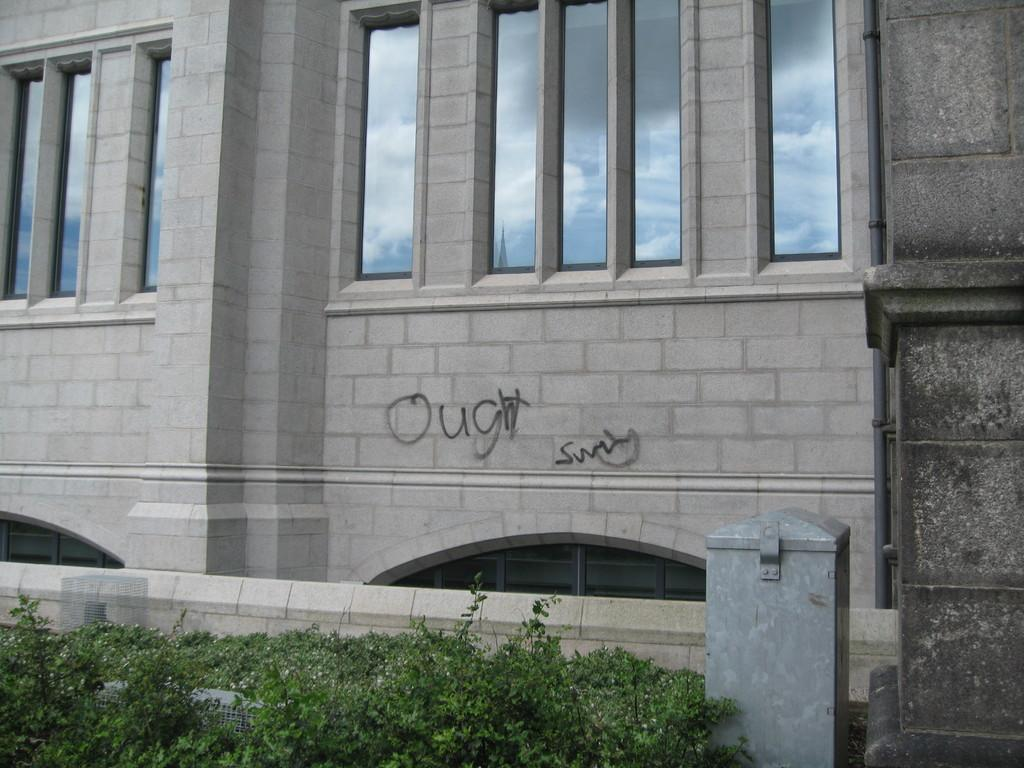What is the main subject in the center of the image? There is a building in the center of the image. What feature can be seen on the building? The building has windows. What type of vegetation is present at the bottom of the image? There are plants at the bottom of the image. What is located to the right side of the image? There is a wall to the right side of the image. How many jellyfish are swimming near the wall in the image? There are no jellyfish present in the image; it features a building, plants, and a wall. What type of muscle is visible in the image? There is no muscle visible in the image. 